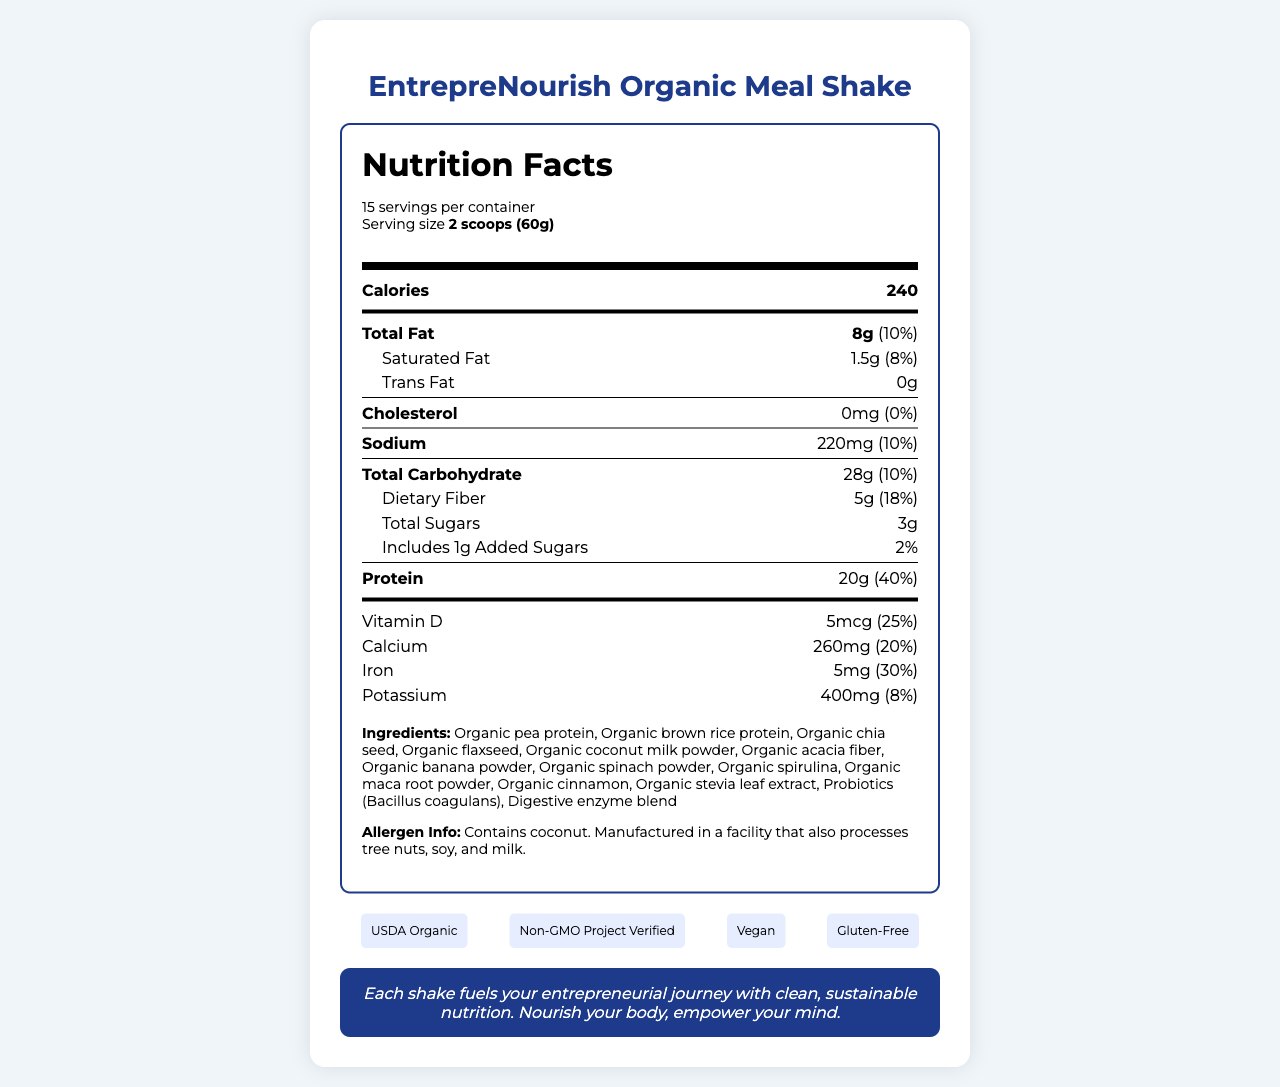What is the serving size of the EntrepreNourish Organic Meal Shake? The serving size is provided at the beginning of the Nutrition Facts label under the product name.
Answer: 2 scoops (60g) How many calories are in one serving of the meal shake? The number of calories per serving is listed prominently under the Nutrition Facts header.
Answer: 240 What is the amount of protein per serving, and what percentage of the daily value does it represent? The protein content is detailed in the nutrition facts, indicating 20g per serving, which corresponds to 40% of the daily value.
Answer: 20g, 40% Which vitamin has the highest daily value percentage? Vitamin B12 has the highest daily value percentage at 100%.
Answer: Vitamin B12 What are the primary ingredients in the EntrepreNourish Organic Meal Shake? The primary ingredients are listed after the nutrition information, beginning with Organic pea protein and Organic brown rice protein.
Answer: Organic pea protein, Organic brown rice protein, Organic chia seed, Organic flaxseed, etc. Which certifications does the EntrepreNourish Organic Meal Shake have? The certifications are displayed in a dedicated section at the bottom of the document.
Answer: USDA Organic, Non-GMO Project Verified, Vegan, Gluten-Free Is this product suitable for vegans? The product is labeled as Vegan in the certifications section.
Answer: Yes What is the origin of the meal shake? The document states that the product is proudly made in California, USA.
Answer: California, USA Which of the following are sustainability claims made by the product? A. Sustainably sourced ingredients B. Recyclable packaging C. Carbon-neutral shipping D. All of the above All listed options are included in the sustainability claims section of the document.
Answer: D. All of the above How many servings per container are there? The servings per container are noted at the beginning of the Nutrition Facts label.
Answer: 15 Does the product contain any added sugars? The amount of added sugars is listed as 1g in the nutrition facts section.
Answer: Yes What percentage of daily value of Vitamin C does this product provide? The daily value percentage for Vitamin C is listed as 35% in the nutrition facts.
Answer: 35% Is the product gluten-free? The product is labeled as Gluten-Free in the certifications section.
Answer: Yes What potential allergens should consumers be aware of in this product? The allergen information notes that the product contains coconut and is manufactured in a facility that processes tree nuts, soy, and milk.
Answer: Coconut Does the product contain any cholesterol? The nutrition label lists 0mg of cholesterol, indicating it contains none.
Answer: No What is the mindset boost offered by the EntrepreNourish Organic Meal Shake? This statement is highlighted in the mindset boost section of the document.
Answer: "Each shake fuels your entrepreneurial journey with clean, sustainable nutrition. Nourish your body, empower your mind." How much dietary fiber is in one serving? The amount of dietary fiber per serving is detailed in the nutrition facts section.
Answer: 5g Does the product make any claims about its packaging? The sustainability claims section mentions recyclable packaging.
Answer: Yes What is the main idea of the document? The entire document presents comprehensive information about the product, emphasizing its nutritional benefits, ingredients, certifications, and suitability for health-conscious, busy entrepreneurs.
Answer: The document provides detailed nutrition facts, ingredient information, certifications, sustainability claims, and a mindset boost for the EntrepreNourish Organic Meal Shake, a sustainably sourced, organic meal replacement shake designed for busy entrepreneurs. What is the price of the EntrepreNourish Organic Meal Shake? The document does not provide any information regarding the price of the product.
Answer: Not enough information 